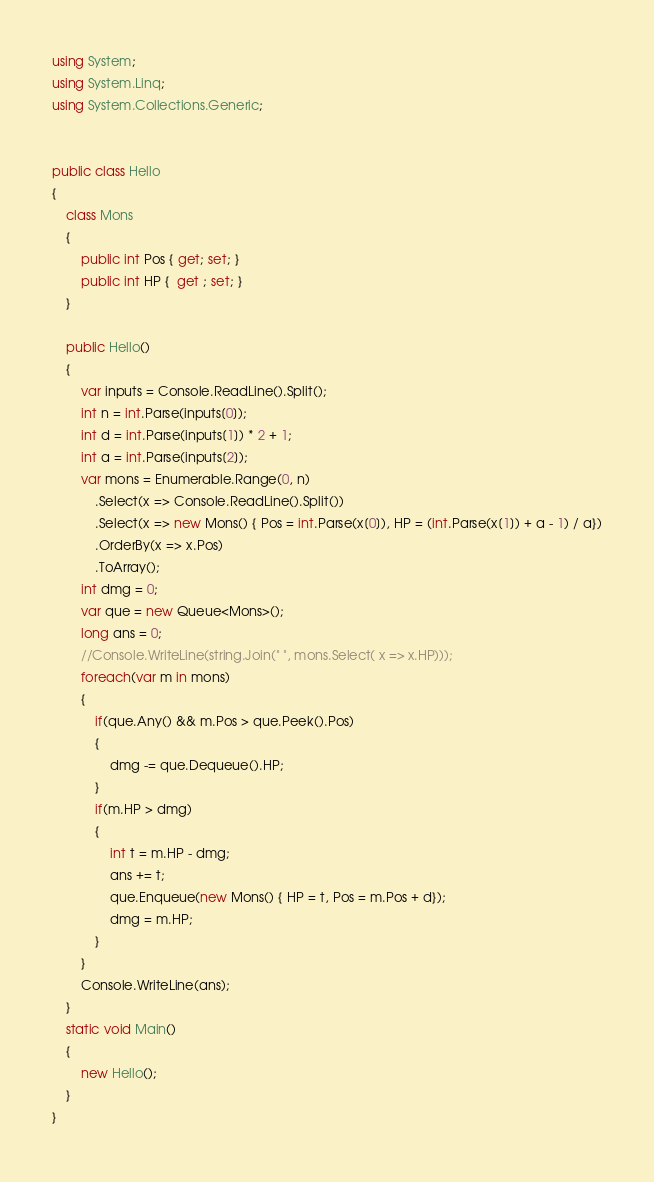<code> <loc_0><loc_0><loc_500><loc_500><_C#_>using System;
using System.Linq;
using System.Collections.Generic;


public class Hello
{
    class Mons
    {
        public int Pos { get; set; }
        public int HP {  get ; set; }
    }

    public Hello()
    {
        var inputs = Console.ReadLine().Split();
        int n = int.Parse(inputs[0]);
        int d = int.Parse(inputs[1]) * 2 + 1;
        int a = int.Parse(inputs[2]);
        var mons = Enumerable.Range(0, n)
            .Select(x => Console.ReadLine().Split())
            .Select(x => new Mons() { Pos = int.Parse(x[0]), HP = (int.Parse(x[1]) + a - 1) / a})
            .OrderBy(x => x.Pos)
            .ToArray();
        int dmg = 0;
        var que = new Queue<Mons>();
        long ans = 0;
        //Console.WriteLine(string.Join(" ", mons.Select( x => x.HP)));
        foreach(var m in mons)
        {
            if(que.Any() && m.Pos > que.Peek().Pos)
            {
                dmg -= que.Dequeue().HP;
            }
            if(m.HP > dmg)
            {
                int t = m.HP - dmg;
                ans += t;
                que.Enqueue(new Mons() { HP = t, Pos = m.Pos + d});
                dmg = m.HP;
            }
        }
        Console.WriteLine(ans);
    }
    static void Main()
    {
        new Hello();
    }
}</code> 